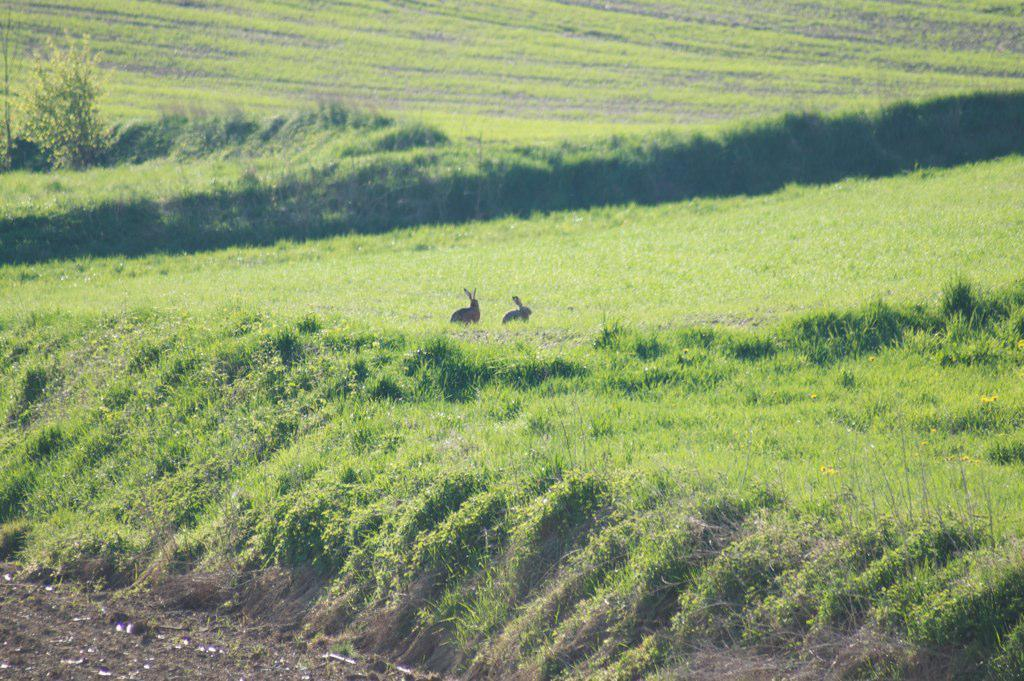How many rabbits are in the image? There are two rabbits in the image. Where are the rabbits located? The rabbits are on the ground. What type of vegetation can be seen in the image? There is grass and plants in the image. What is the woman's opinion on the rabbits' performance in the competition? There is no woman or competition present in the image, so it is not possible to answer that question. 